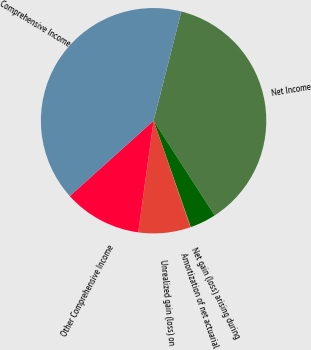<chart> <loc_0><loc_0><loc_500><loc_500><pie_chart><fcel>Net Income<fcel>Net gain (loss) arising during<fcel>Amortization of net actuarial<fcel>Unrealized gain (loss) on<fcel>Other Comprehensive Income<fcel>Comprehensive Income<nl><fcel>36.92%<fcel>3.76%<fcel>0.06%<fcel>7.47%<fcel>11.17%<fcel>40.62%<nl></chart> 